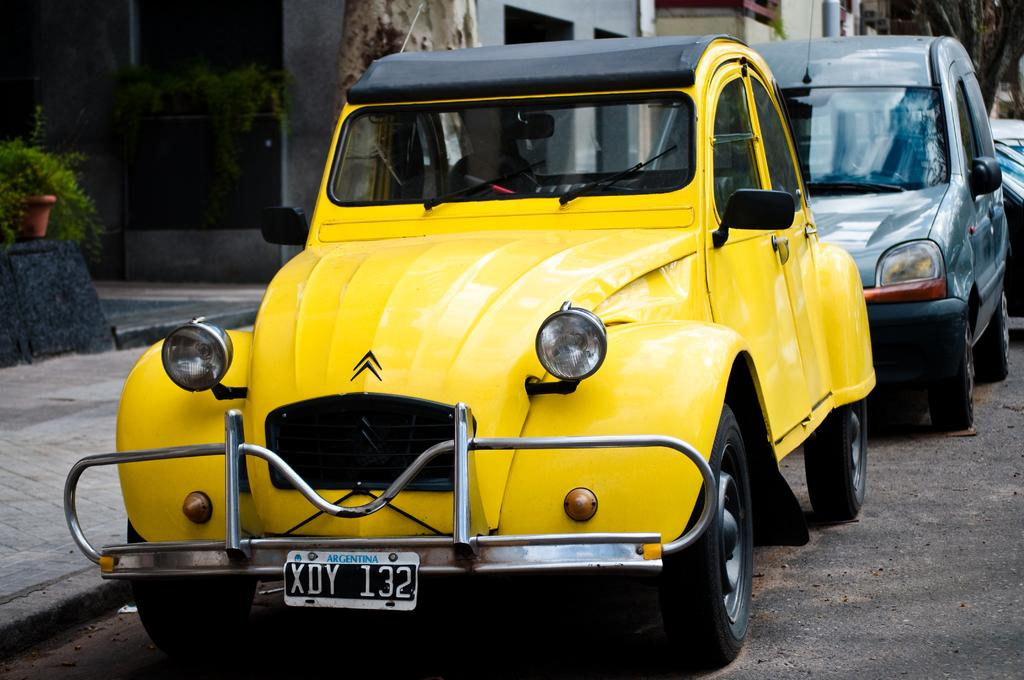Provide a one-sentence caption for the provided image. A yellow car is parked by a curb and the license plate says Argentina. 